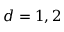<formula> <loc_0><loc_0><loc_500><loc_500>d = 1 , 2</formula> 